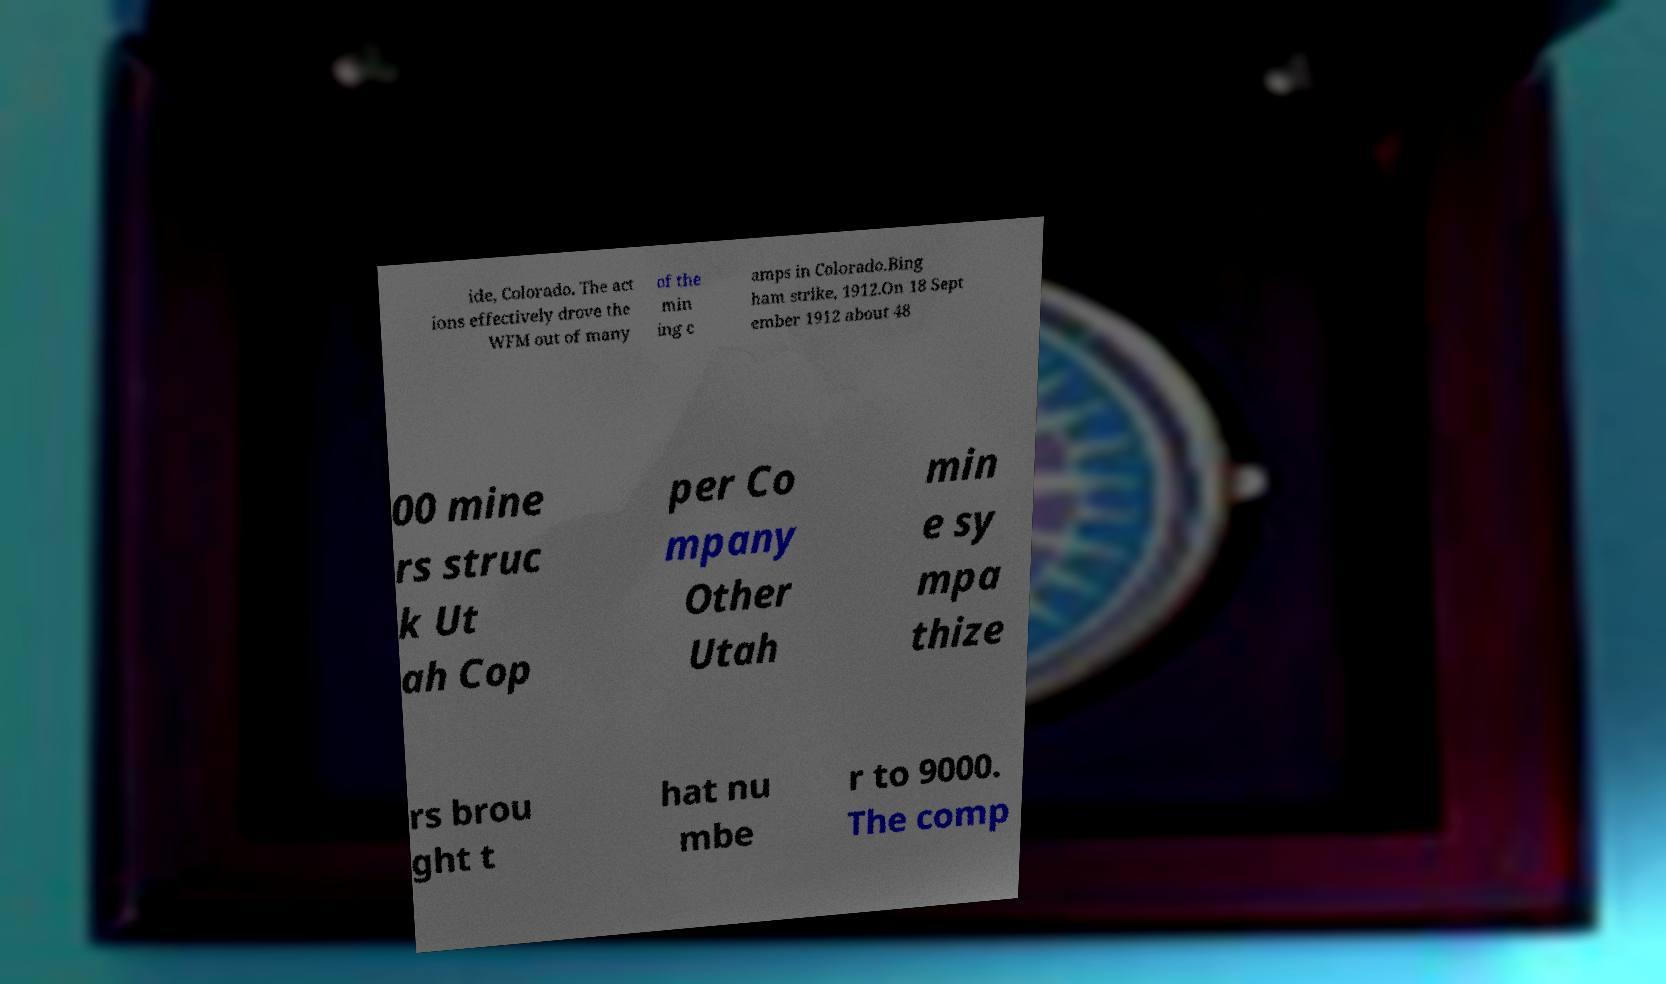What messages or text are displayed in this image? I need them in a readable, typed format. ide, Colorado. The act ions effectively drove the WFM out of many of the min ing c amps in Colorado.Bing ham strike, 1912.On 18 Sept ember 1912 about 48 00 mine rs struc k Ut ah Cop per Co mpany Other Utah min e sy mpa thize rs brou ght t hat nu mbe r to 9000. The comp 